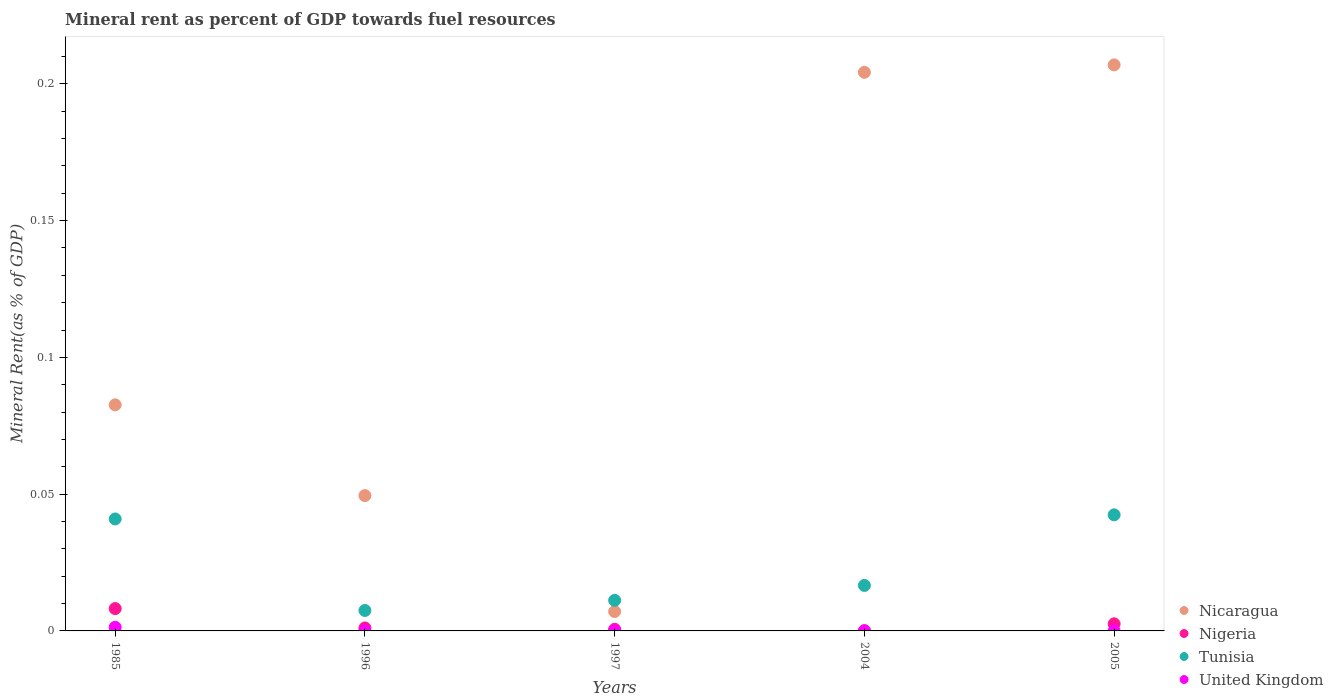What is the mineral rent in United Kingdom in 2005?
Offer a terse response. 7.34291393954371e-6. Across all years, what is the maximum mineral rent in United Kingdom?
Offer a terse response. 0. Across all years, what is the minimum mineral rent in Tunisia?
Offer a very short reply. 0.01. In which year was the mineral rent in Nicaragua maximum?
Provide a short and direct response. 2005. What is the total mineral rent in Tunisia in the graph?
Offer a terse response. 0.12. What is the difference between the mineral rent in Tunisia in 1985 and that in 2005?
Provide a short and direct response. -0. What is the difference between the mineral rent in United Kingdom in 1997 and the mineral rent in Nicaragua in 1996?
Your answer should be very brief. -0.05. What is the average mineral rent in Tunisia per year?
Your answer should be compact. 0.02. In the year 1997, what is the difference between the mineral rent in Tunisia and mineral rent in United Kingdom?
Ensure brevity in your answer.  0.01. In how many years, is the mineral rent in United Kingdom greater than 0.16000000000000003 %?
Keep it short and to the point. 0. What is the ratio of the mineral rent in Tunisia in 1996 to that in 2004?
Ensure brevity in your answer.  0.45. Is the mineral rent in Tunisia in 1996 less than that in 1997?
Provide a short and direct response. Yes. What is the difference between the highest and the second highest mineral rent in Tunisia?
Make the answer very short. 0. What is the difference between the highest and the lowest mineral rent in Nigeria?
Provide a short and direct response. 0.01. In how many years, is the mineral rent in United Kingdom greater than the average mineral rent in United Kingdom taken over all years?
Your response must be concise. 1. Is the sum of the mineral rent in Nigeria in 1996 and 2005 greater than the maximum mineral rent in Nicaragua across all years?
Provide a short and direct response. No. Is it the case that in every year, the sum of the mineral rent in Nicaragua and mineral rent in United Kingdom  is greater than the sum of mineral rent in Tunisia and mineral rent in Nigeria?
Offer a very short reply. Yes. Is it the case that in every year, the sum of the mineral rent in Nicaragua and mineral rent in United Kingdom  is greater than the mineral rent in Nigeria?
Your response must be concise. Yes. How many dotlines are there?
Offer a very short reply. 4. How many years are there in the graph?
Offer a terse response. 5. Are the values on the major ticks of Y-axis written in scientific E-notation?
Offer a very short reply. No. Where does the legend appear in the graph?
Provide a succinct answer. Bottom right. How are the legend labels stacked?
Offer a terse response. Vertical. What is the title of the graph?
Your response must be concise. Mineral rent as percent of GDP towards fuel resources. Does "Japan" appear as one of the legend labels in the graph?
Make the answer very short. No. What is the label or title of the X-axis?
Offer a terse response. Years. What is the label or title of the Y-axis?
Give a very brief answer. Mineral Rent(as % of GDP). What is the Mineral Rent(as % of GDP) in Nicaragua in 1985?
Make the answer very short. 0.08. What is the Mineral Rent(as % of GDP) of Nigeria in 1985?
Your answer should be very brief. 0.01. What is the Mineral Rent(as % of GDP) in Tunisia in 1985?
Make the answer very short. 0.04. What is the Mineral Rent(as % of GDP) in United Kingdom in 1985?
Provide a succinct answer. 0. What is the Mineral Rent(as % of GDP) of Nicaragua in 1996?
Make the answer very short. 0.05. What is the Mineral Rent(as % of GDP) of Nigeria in 1996?
Offer a very short reply. 0. What is the Mineral Rent(as % of GDP) of Tunisia in 1996?
Your answer should be compact. 0.01. What is the Mineral Rent(as % of GDP) in United Kingdom in 1996?
Keep it short and to the point. 1.85883148106212e-5. What is the Mineral Rent(as % of GDP) in Nicaragua in 1997?
Your answer should be very brief. 0.01. What is the Mineral Rent(as % of GDP) in Nigeria in 1997?
Your answer should be very brief. 0. What is the Mineral Rent(as % of GDP) of Tunisia in 1997?
Give a very brief answer. 0.01. What is the Mineral Rent(as % of GDP) in United Kingdom in 1997?
Your answer should be very brief. 1.83749861075143e-6. What is the Mineral Rent(as % of GDP) in Nicaragua in 2004?
Provide a short and direct response. 0.2. What is the Mineral Rent(as % of GDP) in Nigeria in 2004?
Provide a succinct answer. 9.366364684286959e-5. What is the Mineral Rent(as % of GDP) of Tunisia in 2004?
Make the answer very short. 0.02. What is the Mineral Rent(as % of GDP) in United Kingdom in 2004?
Give a very brief answer. 6.19596915094659e-6. What is the Mineral Rent(as % of GDP) in Nicaragua in 2005?
Make the answer very short. 0.21. What is the Mineral Rent(as % of GDP) of Nigeria in 2005?
Your response must be concise. 0. What is the Mineral Rent(as % of GDP) of Tunisia in 2005?
Make the answer very short. 0.04. What is the Mineral Rent(as % of GDP) in United Kingdom in 2005?
Your answer should be compact. 7.34291393954371e-6. Across all years, what is the maximum Mineral Rent(as % of GDP) of Nicaragua?
Your answer should be very brief. 0.21. Across all years, what is the maximum Mineral Rent(as % of GDP) of Nigeria?
Offer a terse response. 0.01. Across all years, what is the maximum Mineral Rent(as % of GDP) in Tunisia?
Provide a short and direct response. 0.04. Across all years, what is the maximum Mineral Rent(as % of GDP) of United Kingdom?
Your answer should be very brief. 0. Across all years, what is the minimum Mineral Rent(as % of GDP) in Nicaragua?
Your response must be concise. 0.01. Across all years, what is the minimum Mineral Rent(as % of GDP) of Nigeria?
Offer a terse response. 9.366364684286959e-5. Across all years, what is the minimum Mineral Rent(as % of GDP) of Tunisia?
Offer a terse response. 0.01. Across all years, what is the minimum Mineral Rent(as % of GDP) in United Kingdom?
Provide a succinct answer. 1.83749861075143e-6. What is the total Mineral Rent(as % of GDP) of Nicaragua in the graph?
Keep it short and to the point. 0.55. What is the total Mineral Rent(as % of GDP) in Nigeria in the graph?
Your response must be concise. 0.01. What is the total Mineral Rent(as % of GDP) of Tunisia in the graph?
Make the answer very short. 0.12. What is the total Mineral Rent(as % of GDP) in United Kingdom in the graph?
Your answer should be compact. 0. What is the difference between the Mineral Rent(as % of GDP) in Nicaragua in 1985 and that in 1996?
Ensure brevity in your answer.  0.03. What is the difference between the Mineral Rent(as % of GDP) of Nigeria in 1985 and that in 1996?
Provide a succinct answer. 0.01. What is the difference between the Mineral Rent(as % of GDP) of Tunisia in 1985 and that in 1996?
Your answer should be very brief. 0.03. What is the difference between the Mineral Rent(as % of GDP) in United Kingdom in 1985 and that in 1996?
Provide a succinct answer. 0. What is the difference between the Mineral Rent(as % of GDP) in Nicaragua in 1985 and that in 1997?
Ensure brevity in your answer.  0.08. What is the difference between the Mineral Rent(as % of GDP) of Nigeria in 1985 and that in 1997?
Provide a succinct answer. 0.01. What is the difference between the Mineral Rent(as % of GDP) of Tunisia in 1985 and that in 1997?
Your answer should be very brief. 0.03. What is the difference between the Mineral Rent(as % of GDP) of United Kingdom in 1985 and that in 1997?
Provide a succinct answer. 0. What is the difference between the Mineral Rent(as % of GDP) of Nicaragua in 1985 and that in 2004?
Keep it short and to the point. -0.12. What is the difference between the Mineral Rent(as % of GDP) of Nigeria in 1985 and that in 2004?
Keep it short and to the point. 0.01. What is the difference between the Mineral Rent(as % of GDP) of Tunisia in 1985 and that in 2004?
Give a very brief answer. 0.02. What is the difference between the Mineral Rent(as % of GDP) of United Kingdom in 1985 and that in 2004?
Offer a very short reply. 0. What is the difference between the Mineral Rent(as % of GDP) of Nicaragua in 1985 and that in 2005?
Provide a short and direct response. -0.12. What is the difference between the Mineral Rent(as % of GDP) of Nigeria in 1985 and that in 2005?
Keep it short and to the point. 0.01. What is the difference between the Mineral Rent(as % of GDP) in Tunisia in 1985 and that in 2005?
Offer a terse response. -0. What is the difference between the Mineral Rent(as % of GDP) in United Kingdom in 1985 and that in 2005?
Your answer should be very brief. 0. What is the difference between the Mineral Rent(as % of GDP) of Nicaragua in 1996 and that in 1997?
Keep it short and to the point. 0.04. What is the difference between the Mineral Rent(as % of GDP) in Tunisia in 1996 and that in 1997?
Your response must be concise. -0. What is the difference between the Mineral Rent(as % of GDP) of United Kingdom in 1996 and that in 1997?
Give a very brief answer. 0. What is the difference between the Mineral Rent(as % of GDP) of Nicaragua in 1996 and that in 2004?
Make the answer very short. -0.15. What is the difference between the Mineral Rent(as % of GDP) of Tunisia in 1996 and that in 2004?
Offer a very short reply. -0.01. What is the difference between the Mineral Rent(as % of GDP) of United Kingdom in 1996 and that in 2004?
Your answer should be compact. 0. What is the difference between the Mineral Rent(as % of GDP) in Nicaragua in 1996 and that in 2005?
Give a very brief answer. -0.16. What is the difference between the Mineral Rent(as % of GDP) of Nigeria in 1996 and that in 2005?
Your answer should be very brief. -0. What is the difference between the Mineral Rent(as % of GDP) in Tunisia in 1996 and that in 2005?
Keep it short and to the point. -0.04. What is the difference between the Mineral Rent(as % of GDP) of Nicaragua in 1997 and that in 2004?
Offer a very short reply. -0.2. What is the difference between the Mineral Rent(as % of GDP) of Nigeria in 1997 and that in 2004?
Your answer should be very brief. 0. What is the difference between the Mineral Rent(as % of GDP) of Tunisia in 1997 and that in 2004?
Provide a succinct answer. -0.01. What is the difference between the Mineral Rent(as % of GDP) of Nicaragua in 1997 and that in 2005?
Ensure brevity in your answer.  -0.2. What is the difference between the Mineral Rent(as % of GDP) in Nigeria in 1997 and that in 2005?
Offer a terse response. -0. What is the difference between the Mineral Rent(as % of GDP) of Tunisia in 1997 and that in 2005?
Your answer should be compact. -0.03. What is the difference between the Mineral Rent(as % of GDP) in Nicaragua in 2004 and that in 2005?
Make the answer very short. -0. What is the difference between the Mineral Rent(as % of GDP) of Nigeria in 2004 and that in 2005?
Ensure brevity in your answer.  -0. What is the difference between the Mineral Rent(as % of GDP) of Tunisia in 2004 and that in 2005?
Your answer should be compact. -0.03. What is the difference between the Mineral Rent(as % of GDP) of Nicaragua in 1985 and the Mineral Rent(as % of GDP) of Nigeria in 1996?
Offer a very short reply. 0.08. What is the difference between the Mineral Rent(as % of GDP) of Nicaragua in 1985 and the Mineral Rent(as % of GDP) of Tunisia in 1996?
Your answer should be compact. 0.08. What is the difference between the Mineral Rent(as % of GDP) of Nicaragua in 1985 and the Mineral Rent(as % of GDP) of United Kingdom in 1996?
Provide a succinct answer. 0.08. What is the difference between the Mineral Rent(as % of GDP) in Nigeria in 1985 and the Mineral Rent(as % of GDP) in Tunisia in 1996?
Give a very brief answer. 0. What is the difference between the Mineral Rent(as % of GDP) of Nigeria in 1985 and the Mineral Rent(as % of GDP) of United Kingdom in 1996?
Give a very brief answer. 0.01. What is the difference between the Mineral Rent(as % of GDP) in Tunisia in 1985 and the Mineral Rent(as % of GDP) in United Kingdom in 1996?
Ensure brevity in your answer.  0.04. What is the difference between the Mineral Rent(as % of GDP) in Nicaragua in 1985 and the Mineral Rent(as % of GDP) in Nigeria in 1997?
Make the answer very short. 0.08. What is the difference between the Mineral Rent(as % of GDP) in Nicaragua in 1985 and the Mineral Rent(as % of GDP) in Tunisia in 1997?
Provide a short and direct response. 0.07. What is the difference between the Mineral Rent(as % of GDP) of Nicaragua in 1985 and the Mineral Rent(as % of GDP) of United Kingdom in 1997?
Give a very brief answer. 0.08. What is the difference between the Mineral Rent(as % of GDP) in Nigeria in 1985 and the Mineral Rent(as % of GDP) in Tunisia in 1997?
Ensure brevity in your answer.  -0. What is the difference between the Mineral Rent(as % of GDP) of Nigeria in 1985 and the Mineral Rent(as % of GDP) of United Kingdom in 1997?
Ensure brevity in your answer.  0.01. What is the difference between the Mineral Rent(as % of GDP) in Tunisia in 1985 and the Mineral Rent(as % of GDP) in United Kingdom in 1997?
Make the answer very short. 0.04. What is the difference between the Mineral Rent(as % of GDP) in Nicaragua in 1985 and the Mineral Rent(as % of GDP) in Nigeria in 2004?
Your response must be concise. 0.08. What is the difference between the Mineral Rent(as % of GDP) of Nicaragua in 1985 and the Mineral Rent(as % of GDP) of Tunisia in 2004?
Your answer should be very brief. 0.07. What is the difference between the Mineral Rent(as % of GDP) in Nicaragua in 1985 and the Mineral Rent(as % of GDP) in United Kingdom in 2004?
Give a very brief answer. 0.08. What is the difference between the Mineral Rent(as % of GDP) of Nigeria in 1985 and the Mineral Rent(as % of GDP) of Tunisia in 2004?
Keep it short and to the point. -0.01. What is the difference between the Mineral Rent(as % of GDP) of Nigeria in 1985 and the Mineral Rent(as % of GDP) of United Kingdom in 2004?
Provide a succinct answer. 0.01. What is the difference between the Mineral Rent(as % of GDP) of Tunisia in 1985 and the Mineral Rent(as % of GDP) of United Kingdom in 2004?
Keep it short and to the point. 0.04. What is the difference between the Mineral Rent(as % of GDP) of Nicaragua in 1985 and the Mineral Rent(as % of GDP) of Nigeria in 2005?
Your response must be concise. 0.08. What is the difference between the Mineral Rent(as % of GDP) of Nicaragua in 1985 and the Mineral Rent(as % of GDP) of Tunisia in 2005?
Provide a succinct answer. 0.04. What is the difference between the Mineral Rent(as % of GDP) of Nicaragua in 1985 and the Mineral Rent(as % of GDP) of United Kingdom in 2005?
Provide a short and direct response. 0.08. What is the difference between the Mineral Rent(as % of GDP) in Nigeria in 1985 and the Mineral Rent(as % of GDP) in Tunisia in 2005?
Your response must be concise. -0.03. What is the difference between the Mineral Rent(as % of GDP) of Nigeria in 1985 and the Mineral Rent(as % of GDP) of United Kingdom in 2005?
Keep it short and to the point. 0.01. What is the difference between the Mineral Rent(as % of GDP) of Tunisia in 1985 and the Mineral Rent(as % of GDP) of United Kingdom in 2005?
Give a very brief answer. 0.04. What is the difference between the Mineral Rent(as % of GDP) in Nicaragua in 1996 and the Mineral Rent(as % of GDP) in Nigeria in 1997?
Offer a terse response. 0.05. What is the difference between the Mineral Rent(as % of GDP) in Nicaragua in 1996 and the Mineral Rent(as % of GDP) in Tunisia in 1997?
Make the answer very short. 0.04. What is the difference between the Mineral Rent(as % of GDP) in Nicaragua in 1996 and the Mineral Rent(as % of GDP) in United Kingdom in 1997?
Keep it short and to the point. 0.05. What is the difference between the Mineral Rent(as % of GDP) in Nigeria in 1996 and the Mineral Rent(as % of GDP) in Tunisia in 1997?
Provide a short and direct response. -0.01. What is the difference between the Mineral Rent(as % of GDP) in Nigeria in 1996 and the Mineral Rent(as % of GDP) in United Kingdom in 1997?
Give a very brief answer. 0. What is the difference between the Mineral Rent(as % of GDP) of Tunisia in 1996 and the Mineral Rent(as % of GDP) of United Kingdom in 1997?
Offer a terse response. 0.01. What is the difference between the Mineral Rent(as % of GDP) of Nicaragua in 1996 and the Mineral Rent(as % of GDP) of Nigeria in 2004?
Provide a succinct answer. 0.05. What is the difference between the Mineral Rent(as % of GDP) in Nicaragua in 1996 and the Mineral Rent(as % of GDP) in Tunisia in 2004?
Offer a terse response. 0.03. What is the difference between the Mineral Rent(as % of GDP) of Nicaragua in 1996 and the Mineral Rent(as % of GDP) of United Kingdom in 2004?
Provide a short and direct response. 0.05. What is the difference between the Mineral Rent(as % of GDP) in Nigeria in 1996 and the Mineral Rent(as % of GDP) in Tunisia in 2004?
Provide a succinct answer. -0.02. What is the difference between the Mineral Rent(as % of GDP) of Nigeria in 1996 and the Mineral Rent(as % of GDP) of United Kingdom in 2004?
Offer a very short reply. 0. What is the difference between the Mineral Rent(as % of GDP) of Tunisia in 1996 and the Mineral Rent(as % of GDP) of United Kingdom in 2004?
Make the answer very short. 0.01. What is the difference between the Mineral Rent(as % of GDP) of Nicaragua in 1996 and the Mineral Rent(as % of GDP) of Nigeria in 2005?
Offer a terse response. 0.05. What is the difference between the Mineral Rent(as % of GDP) of Nicaragua in 1996 and the Mineral Rent(as % of GDP) of Tunisia in 2005?
Offer a terse response. 0.01. What is the difference between the Mineral Rent(as % of GDP) in Nicaragua in 1996 and the Mineral Rent(as % of GDP) in United Kingdom in 2005?
Give a very brief answer. 0.05. What is the difference between the Mineral Rent(as % of GDP) of Nigeria in 1996 and the Mineral Rent(as % of GDP) of Tunisia in 2005?
Your response must be concise. -0.04. What is the difference between the Mineral Rent(as % of GDP) of Nigeria in 1996 and the Mineral Rent(as % of GDP) of United Kingdom in 2005?
Your response must be concise. 0. What is the difference between the Mineral Rent(as % of GDP) in Tunisia in 1996 and the Mineral Rent(as % of GDP) in United Kingdom in 2005?
Your answer should be compact. 0.01. What is the difference between the Mineral Rent(as % of GDP) in Nicaragua in 1997 and the Mineral Rent(as % of GDP) in Nigeria in 2004?
Make the answer very short. 0.01. What is the difference between the Mineral Rent(as % of GDP) of Nicaragua in 1997 and the Mineral Rent(as % of GDP) of Tunisia in 2004?
Offer a very short reply. -0.01. What is the difference between the Mineral Rent(as % of GDP) of Nicaragua in 1997 and the Mineral Rent(as % of GDP) of United Kingdom in 2004?
Offer a very short reply. 0.01. What is the difference between the Mineral Rent(as % of GDP) in Nigeria in 1997 and the Mineral Rent(as % of GDP) in Tunisia in 2004?
Ensure brevity in your answer.  -0.02. What is the difference between the Mineral Rent(as % of GDP) in Nigeria in 1997 and the Mineral Rent(as % of GDP) in United Kingdom in 2004?
Your answer should be very brief. 0. What is the difference between the Mineral Rent(as % of GDP) in Tunisia in 1997 and the Mineral Rent(as % of GDP) in United Kingdom in 2004?
Ensure brevity in your answer.  0.01. What is the difference between the Mineral Rent(as % of GDP) in Nicaragua in 1997 and the Mineral Rent(as % of GDP) in Nigeria in 2005?
Keep it short and to the point. 0. What is the difference between the Mineral Rent(as % of GDP) in Nicaragua in 1997 and the Mineral Rent(as % of GDP) in Tunisia in 2005?
Your answer should be very brief. -0.04. What is the difference between the Mineral Rent(as % of GDP) in Nicaragua in 1997 and the Mineral Rent(as % of GDP) in United Kingdom in 2005?
Offer a terse response. 0.01. What is the difference between the Mineral Rent(as % of GDP) in Nigeria in 1997 and the Mineral Rent(as % of GDP) in Tunisia in 2005?
Ensure brevity in your answer.  -0.04. What is the difference between the Mineral Rent(as % of GDP) in Nigeria in 1997 and the Mineral Rent(as % of GDP) in United Kingdom in 2005?
Make the answer very short. 0. What is the difference between the Mineral Rent(as % of GDP) in Tunisia in 1997 and the Mineral Rent(as % of GDP) in United Kingdom in 2005?
Provide a short and direct response. 0.01. What is the difference between the Mineral Rent(as % of GDP) in Nicaragua in 2004 and the Mineral Rent(as % of GDP) in Nigeria in 2005?
Provide a succinct answer. 0.2. What is the difference between the Mineral Rent(as % of GDP) in Nicaragua in 2004 and the Mineral Rent(as % of GDP) in Tunisia in 2005?
Your answer should be very brief. 0.16. What is the difference between the Mineral Rent(as % of GDP) of Nicaragua in 2004 and the Mineral Rent(as % of GDP) of United Kingdom in 2005?
Your response must be concise. 0.2. What is the difference between the Mineral Rent(as % of GDP) of Nigeria in 2004 and the Mineral Rent(as % of GDP) of Tunisia in 2005?
Provide a short and direct response. -0.04. What is the difference between the Mineral Rent(as % of GDP) in Tunisia in 2004 and the Mineral Rent(as % of GDP) in United Kingdom in 2005?
Your answer should be very brief. 0.02. What is the average Mineral Rent(as % of GDP) of Nicaragua per year?
Make the answer very short. 0.11. What is the average Mineral Rent(as % of GDP) of Nigeria per year?
Offer a very short reply. 0. What is the average Mineral Rent(as % of GDP) of Tunisia per year?
Provide a short and direct response. 0.02. In the year 1985, what is the difference between the Mineral Rent(as % of GDP) in Nicaragua and Mineral Rent(as % of GDP) in Nigeria?
Provide a short and direct response. 0.07. In the year 1985, what is the difference between the Mineral Rent(as % of GDP) of Nicaragua and Mineral Rent(as % of GDP) of Tunisia?
Ensure brevity in your answer.  0.04. In the year 1985, what is the difference between the Mineral Rent(as % of GDP) of Nicaragua and Mineral Rent(as % of GDP) of United Kingdom?
Your answer should be very brief. 0.08. In the year 1985, what is the difference between the Mineral Rent(as % of GDP) of Nigeria and Mineral Rent(as % of GDP) of Tunisia?
Your response must be concise. -0.03. In the year 1985, what is the difference between the Mineral Rent(as % of GDP) of Nigeria and Mineral Rent(as % of GDP) of United Kingdom?
Offer a terse response. 0.01. In the year 1985, what is the difference between the Mineral Rent(as % of GDP) of Tunisia and Mineral Rent(as % of GDP) of United Kingdom?
Your answer should be very brief. 0.04. In the year 1996, what is the difference between the Mineral Rent(as % of GDP) of Nicaragua and Mineral Rent(as % of GDP) of Nigeria?
Provide a short and direct response. 0.05. In the year 1996, what is the difference between the Mineral Rent(as % of GDP) of Nicaragua and Mineral Rent(as % of GDP) of Tunisia?
Provide a succinct answer. 0.04. In the year 1996, what is the difference between the Mineral Rent(as % of GDP) of Nicaragua and Mineral Rent(as % of GDP) of United Kingdom?
Provide a succinct answer. 0.05. In the year 1996, what is the difference between the Mineral Rent(as % of GDP) in Nigeria and Mineral Rent(as % of GDP) in Tunisia?
Offer a terse response. -0.01. In the year 1996, what is the difference between the Mineral Rent(as % of GDP) in Nigeria and Mineral Rent(as % of GDP) in United Kingdom?
Your answer should be very brief. 0. In the year 1996, what is the difference between the Mineral Rent(as % of GDP) of Tunisia and Mineral Rent(as % of GDP) of United Kingdom?
Offer a very short reply. 0.01. In the year 1997, what is the difference between the Mineral Rent(as % of GDP) in Nicaragua and Mineral Rent(as % of GDP) in Nigeria?
Your answer should be compact. 0.01. In the year 1997, what is the difference between the Mineral Rent(as % of GDP) of Nicaragua and Mineral Rent(as % of GDP) of Tunisia?
Your response must be concise. -0. In the year 1997, what is the difference between the Mineral Rent(as % of GDP) of Nicaragua and Mineral Rent(as % of GDP) of United Kingdom?
Provide a succinct answer. 0.01. In the year 1997, what is the difference between the Mineral Rent(as % of GDP) of Nigeria and Mineral Rent(as % of GDP) of Tunisia?
Your answer should be very brief. -0.01. In the year 1997, what is the difference between the Mineral Rent(as % of GDP) of Nigeria and Mineral Rent(as % of GDP) of United Kingdom?
Provide a short and direct response. 0. In the year 1997, what is the difference between the Mineral Rent(as % of GDP) in Tunisia and Mineral Rent(as % of GDP) in United Kingdom?
Ensure brevity in your answer.  0.01. In the year 2004, what is the difference between the Mineral Rent(as % of GDP) of Nicaragua and Mineral Rent(as % of GDP) of Nigeria?
Provide a short and direct response. 0.2. In the year 2004, what is the difference between the Mineral Rent(as % of GDP) in Nicaragua and Mineral Rent(as % of GDP) in Tunisia?
Offer a terse response. 0.19. In the year 2004, what is the difference between the Mineral Rent(as % of GDP) of Nicaragua and Mineral Rent(as % of GDP) of United Kingdom?
Provide a succinct answer. 0.2. In the year 2004, what is the difference between the Mineral Rent(as % of GDP) of Nigeria and Mineral Rent(as % of GDP) of Tunisia?
Ensure brevity in your answer.  -0.02. In the year 2004, what is the difference between the Mineral Rent(as % of GDP) in Tunisia and Mineral Rent(as % of GDP) in United Kingdom?
Keep it short and to the point. 0.02. In the year 2005, what is the difference between the Mineral Rent(as % of GDP) of Nicaragua and Mineral Rent(as % of GDP) of Nigeria?
Offer a terse response. 0.2. In the year 2005, what is the difference between the Mineral Rent(as % of GDP) of Nicaragua and Mineral Rent(as % of GDP) of Tunisia?
Offer a very short reply. 0.16. In the year 2005, what is the difference between the Mineral Rent(as % of GDP) of Nicaragua and Mineral Rent(as % of GDP) of United Kingdom?
Your response must be concise. 0.21. In the year 2005, what is the difference between the Mineral Rent(as % of GDP) in Nigeria and Mineral Rent(as % of GDP) in Tunisia?
Give a very brief answer. -0.04. In the year 2005, what is the difference between the Mineral Rent(as % of GDP) of Nigeria and Mineral Rent(as % of GDP) of United Kingdom?
Offer a terse response. 0. In the year 2005, what is the difference between the Mineral Rent(as % of GDP) in Tunisia and Mineral Rent(as % of GDP) in United Kingdom?
Offer a terse response. 0.04. What is the ratio of the Mineral Rent(as % of GDP) of Nicaragua in 1985 to that in 1996?
Your response must be concise. 1.67. What is the ratio of the Mineral Rent(as % of GDP) in Nigeria in 1985 to that in 1996?
Your response must be concise. 7.5. What is the ratio of the Mineral Rent(as % of GDP) of Tunisia in 1985 to that in 1996?
Your answer should be compact. 5.48. What is the ratio of the Mineral Rent(as % of GDP) in United Kingdom in 1985 to that in 1996?
Offer a terse response. 71.43. What is the ratio of the Mineral Rent(as % of GDP) in Nicaragua in 1985 to that in 1997?
Offer a very short reply. 11.66. What is the ratio of the Mineral Rent(as % of GDP) in Nigeria in 1985 to that in 1997?
Your answer should be compact. 13.92. What is the ratio of the Mineral Rent(as % of GDP) of Tunisia in 1985 to that in 1997?
Your response must be concise. 3.66. What is the ratio of the Mineral Rent(as % of GDP) in United Kingdom in 1985 to that in 1997?
Offer a terse response. 722.58. What is the ratio of the Mineral Rent(as % of GDP) in Nicaragua in 1985 to that in 2004?
Make the answer very short. 0.4. What is the ratio of the Mineral Rent(as % of GDP) of Nigeria in 1985 to that in 2004?
Your answer should be very brief. 87.23. What is the ratio of the Mineral Rent(as % of GDP) of Tunisia in 1985 to that in 2004?
Keep it short and to the point. 2.46. What is the ratio of the Mineral Rent(as % of GDP) in United Kingdom in 1985 to that in 2004?
Your answer should be very brief. 214.29. What is the ratio of the Mineral Rent(as % of GDP) of Nicaragua in 1985 to that in 2005?
Keep it short and to the point. 0.4. What is the ratio of the Mineral Rent(as % of GDP) of Nigeria in 1985 to that in 2005?
Your answer should be compact. 3.15. What is the ratio of the Mineral Rent(as % of GDP) of Tunisia in 1985 to that in 2005?
Make the answer very short. 0.96. What is the ratio of the Mineral Rent(as % of GDP) in United Kingdom in 1985 to that in 2005?
Offer a terse response. 180.82. What is the ratio of the Mineral Rent(as % of GDP) of Nicaragua in 1996 to that in 1997?
Offer a terse response. 6.98. What is the ratio of the Mineral Rent(as % of GDP) in Nigeria in 1996 to that in 1997?
Provide a succinct answer. 1.86. What is the ratio of the Mineral Rent(as % of GDP) of Tunisia in 1996 to that in 1997?
Give a very brief answer. 0.67. What is the ratio of the Mineral Rent(as % of GDP) in United Kingdom in 1996 to that in 1997?
Give a very brief answer. 10.12. What is the ratio of the Mineral Rent(as % of GDP) of Nicaragua in 1996 to that in 2004?
Give a very brief answer. 0.24. What is the ratio of the Mineral Rent(as % of GDP) of Nigeria in 1996 to that in 2004?
Provide a succinct answer. 11.63. What is the ratio of the Mineral Rent(as % of GDP) in Tunisia in 1996 to that in 2004?
Keep it short and to the point. 0.45. What is the ratio of the Mineral Rent(as % of GDP) of United Kingdom in 1996 to that in 2004?
Your answer should be compact. 3. What is the ratio of the Mineral Rent(as % of GDP) in Nicaragua in 1996 to that in 2005?
Ensure brevity in your answer.  0.24. What is the ratio of the Mineral Rent(as % of GDP) in Nigeria in 1996 to that in 2005?
Your response must be concise. 0.42. What is the ratio of the Mineral Rent(as % of GDP) in Tunisia in 1996 to that in 2005?
Provide a short and direct response. 0.18. What is the ratio of the Mineral Rent(as % of GDP) in United Kingdom in 1996 to that in 2005?
Keep it short and to the point. 2.53. What is the ratio of the Mineral Rent(as % of GDP) of Nicaragua in 1997 to that in 2004?
Your answer should be compact. 0.03. What is the ratio of the Mineral Rent(as % of GDP) in Nigeria in 1997 to that in 2004?
Provide a short and direct response. 6.27. What is the ratio of the Mineral Rent(as % of GDP) of Tunisia in 1997 to that in 2004?
Give a very brief answer. 0.67. What is the ratio of the Mineral Rent(as % of GDP) in United Kingdom in 1997 to that in 2004?
Provide a short and direct response. 0.3. What is the ratio of the Mineral Rent(as % of GDP) in Nicaragua in 1997 to that in 2005?
Provide a short and direct response. 0.03. What is the ratio of the Mineral Rent(as % of GDP) of Nigeria in 1997 to that in 2005?
Make the answer very short. 0.23. What is the ratio of the Mineral Rent(as % of GDP) of Tunisia in 1997 to that in 2005?
Your answer should be compact. 0.26. What is the ratio of the Mineral Rent(as % of GDP) of United Kingdom in 1997 to that in 2005?
Keep it short and to the point. 0.25. What is the ratio of the Mineral Rent(as % of GDP) in Nigeria in 2004 to that in 2005?
Keep it short and to the point. 0.04. What is the ratio of the Mineral Rent(as % of GDP) of Tunisia in 2004 to that in 2005?
Give a very brief answer. 0.39. What is the ratio of the Mineral Rent(as % of GDP) in United Kingdom in 2004 to that in 2005?
Keep it short and to the point. 0.84. What is the difference between the highest and the second highest Mineral Rent(as % of GDP) in Nicaragua?
Make the answer very short. 0. What is the difference between the highest and the second highest Mineral Rent(as % of GDP) in Nigeria?
Provide a succinct answer. 0.01. What is the difference between the highest and the second highest Mineral Rent(as % of GDP) in Tunisia?
Provide a succinct answer. 0. What is the difference between the highest and the second highest Mineral Rent(as % of GDP) of United Kingdom?
Ensure brevity in your answer.  0. What is the difference between the highest and the lowest Mineral Rent(as % of GDP) of Nicaragua?
Your response must be concise. 0.2. What is the difference between the highest and the lowest Mineral Rent(as % of GDP) in Nigeria?
Keep it short and to the point. 0.01. What is the difference between the highest and the lowest Mineral Rent(as % of GDP) in Tunisia?
Give a very brief answer. 0.04. What is the difference between the highest and the lowest Mineral Rent(as % of GDP) of United Kingdom?
Provide a short and direct response. 0. 